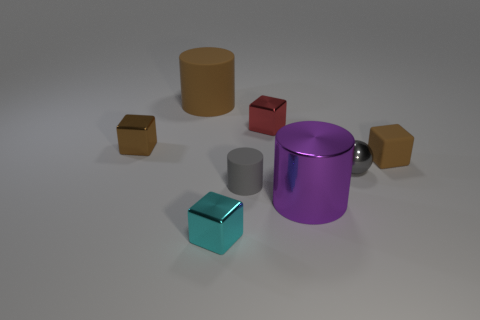What is the size of the other gray object that is the same shape as the big matte object?
Ensure brevity in your answer.  Small. What number of other brown cylinders have the same material as the small cylinder?
Keep it short and to the point. 1. How many metallic things are behind the large cylinder that is on the right side of the tiny red cube?
Keep it short and to the point. 3. There is a metallic sphere; are there any rubber cylinders right of it?
Your answer should be compact. No. Do the tiny object that is in front of the big purple metal thing and the gray metal object have the same shape?
Offer a terse response. No. What is the material of the tiny cylinder that is the same color as the small shiny sphere?
Ensure brevity in your answer.  Rubber. How many other small spheres are the same color as the small sphere?
Ensure brevity in your answer.  0. What shape is the brown rubber thing that is in front of the cube to the left of the big brown cylinder?
Keep it short and to the point. Cube. Are there any tiny brown rubber things that have the same shape as the small red metallic thing?
Provide a succinct answer. Yes. Does the tiny ball have the same color as the tiny metallic cube that is behind the brown metal thing?
Provide a succinct answer. No. 